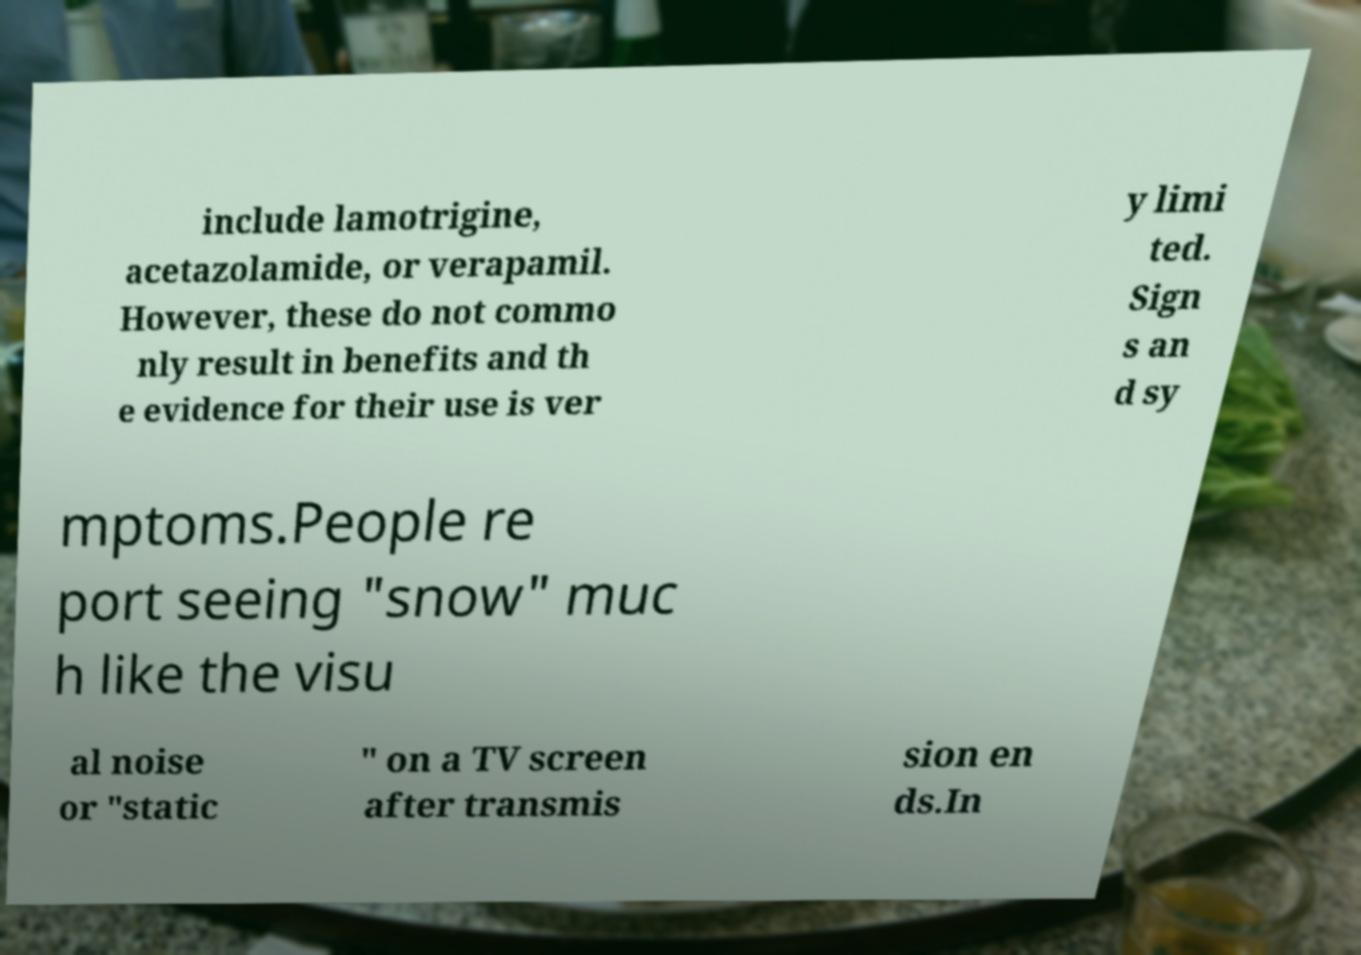Please identify and transcribe the text found in this image. include lamotrigine, acetazolamide, or verapamil. However, these do not commo nly result in benefits and th e evidence for their use is ver y limi ted. Sign s an d sy mptoms.People re port seeing "snow" muc h like the visu al noise or "static " on a TV screen after transmis sion en ds.In 